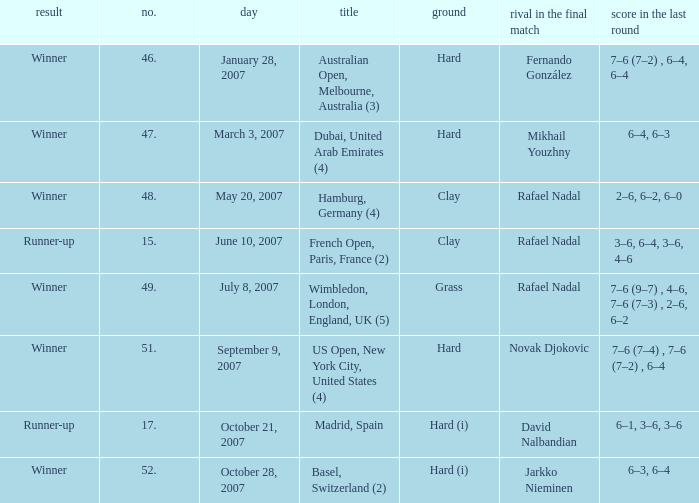When the  score in the final is 3–6, 6–4, 3–6, 4–6, who are all the opponents in the final? Rafael Nadal. 